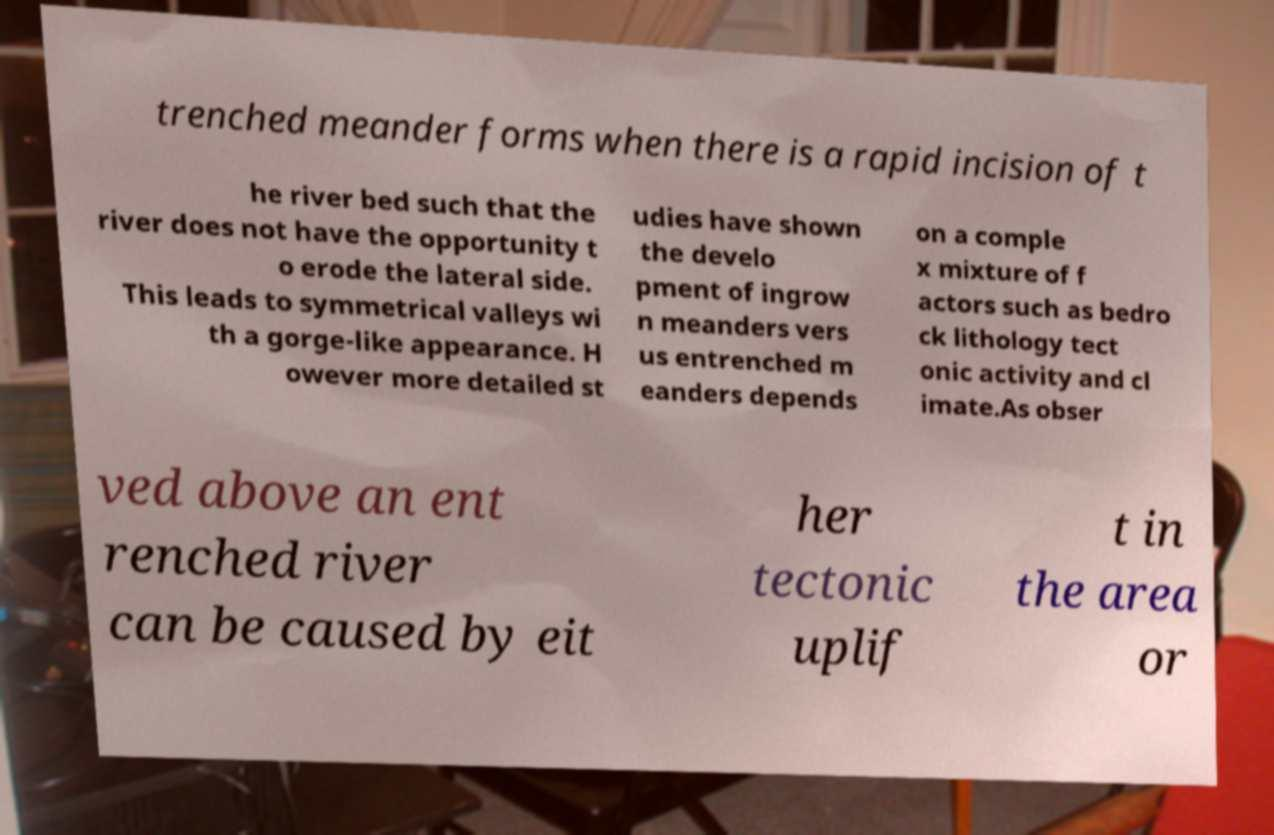I need the written content from this picture converted into text. Can you do that? trenched meander forms when there is a rapid incision of t he river bed such that the river does not have the opportunity t o erode the lateral side. This leads to symmetrical valleys wi th a gorge-like appearance. H owever more detailed st udies have shown the develo pment of ingrow n meanders vers us entrenched m eanders depends on a comple x mixture of f actors such as bedro ck lithology tect onic activity and cl imate.As obser ved above an ent renched river can be caused by eit her tectonic uplif t in the area or 